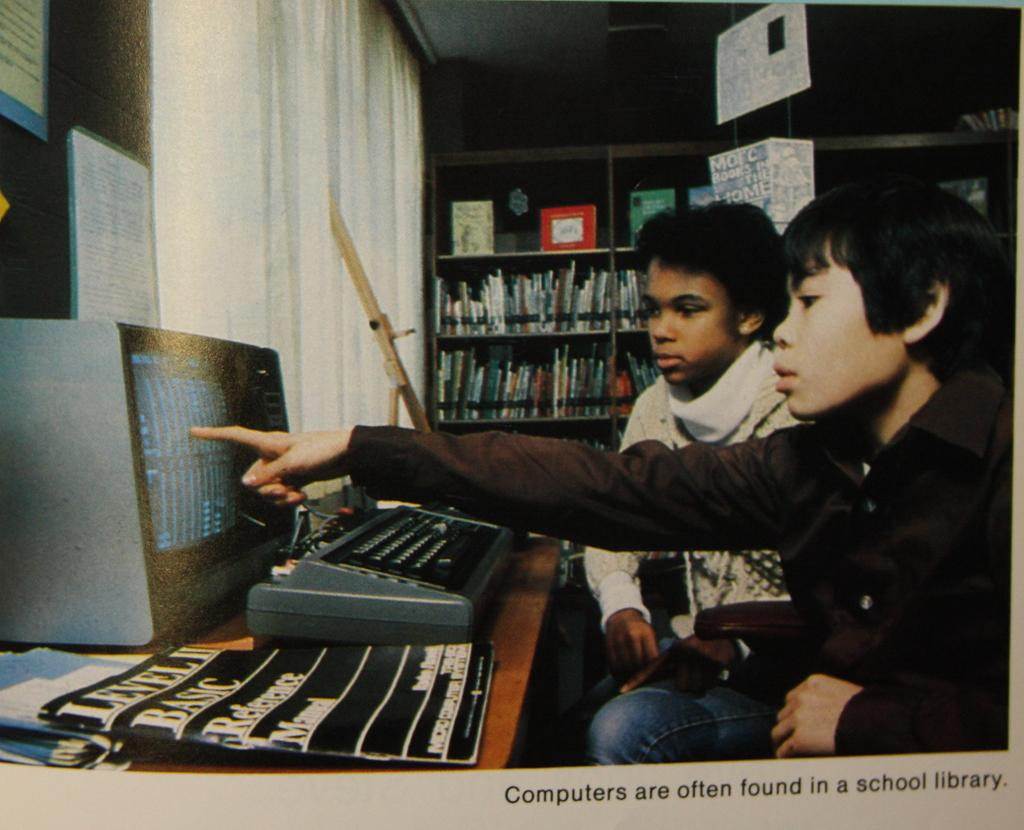<image>
Provide a brief description of the given image. An image from long ago shows two children and an old computer and is captioned "Computers are often found in a school library." 